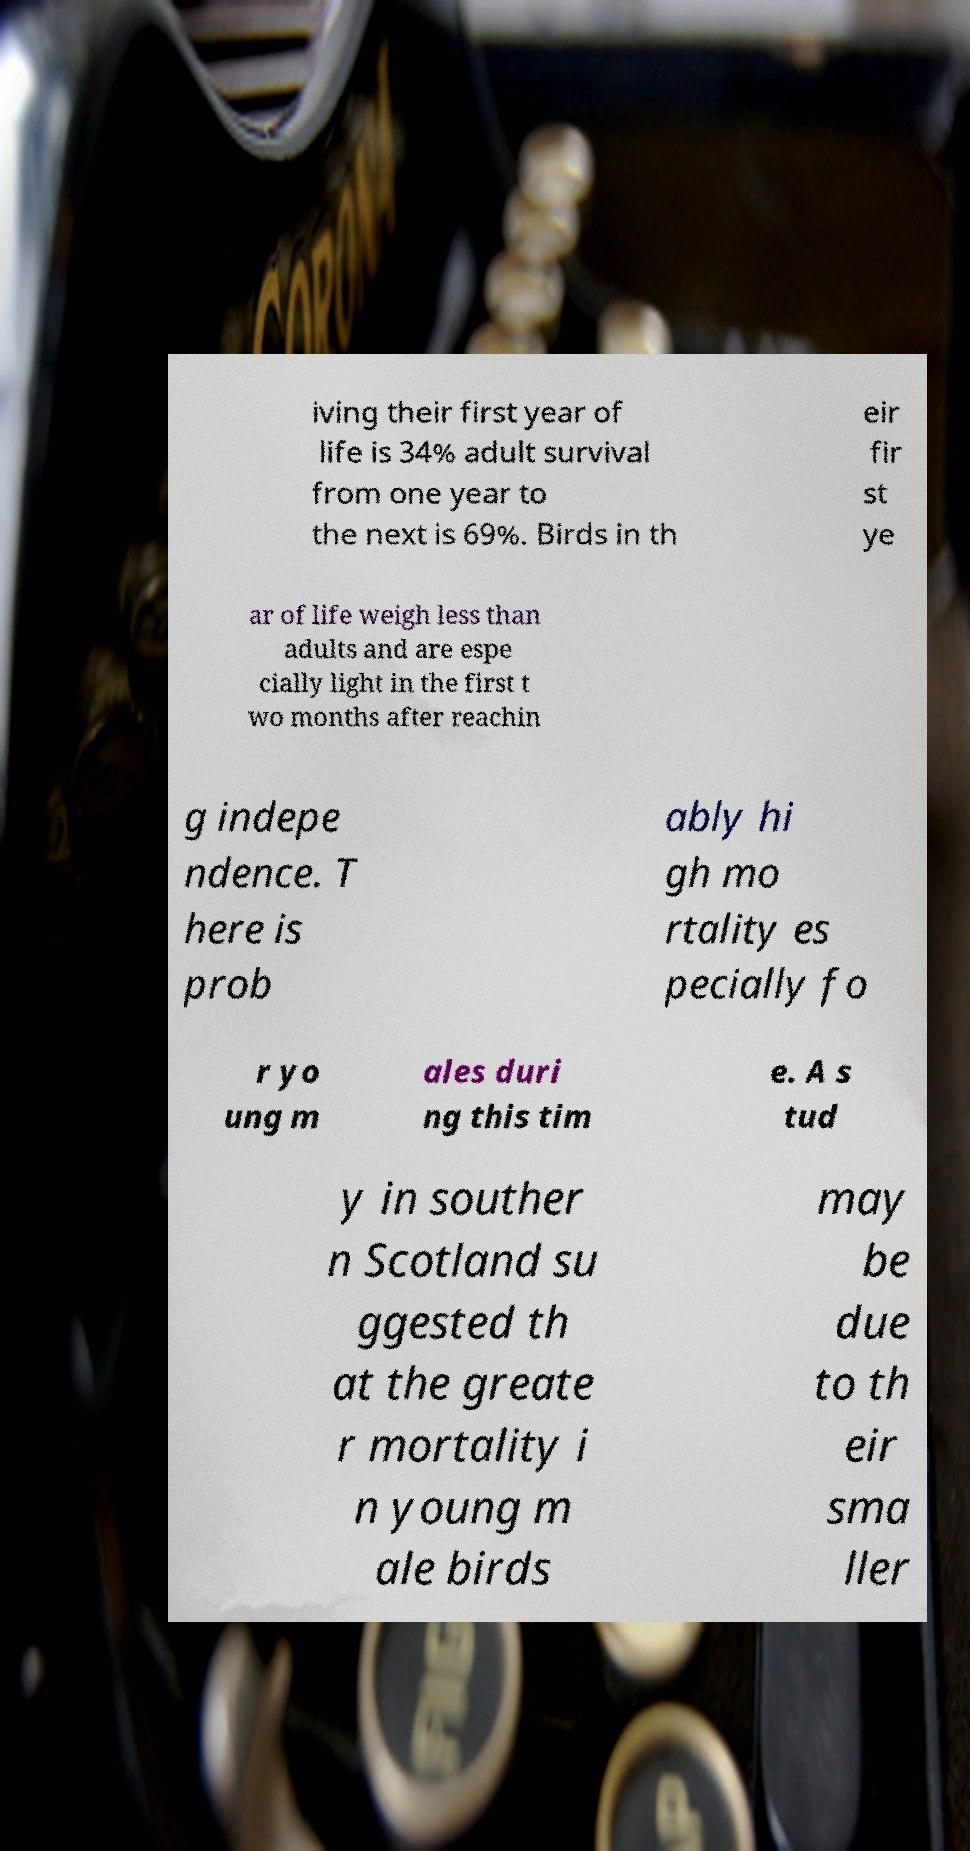For documentation purposes, I need the text within this image transcribed. Could you provide that? iving their first year of life is 34% adult survival from one year to the next is 69%. Birds in th eir fir st ye ar of life weigh less than adults and are espe cially light in the first t wo months after reachin g indepe ndence. T here is prob ably hi gh mo rtality es pecially fo r yo ung m ales duri ng this tim e. A s tud y in souther n Scotland su ggested th at the greate r mortality i n young m ale birds may be due to th eir sma ller 